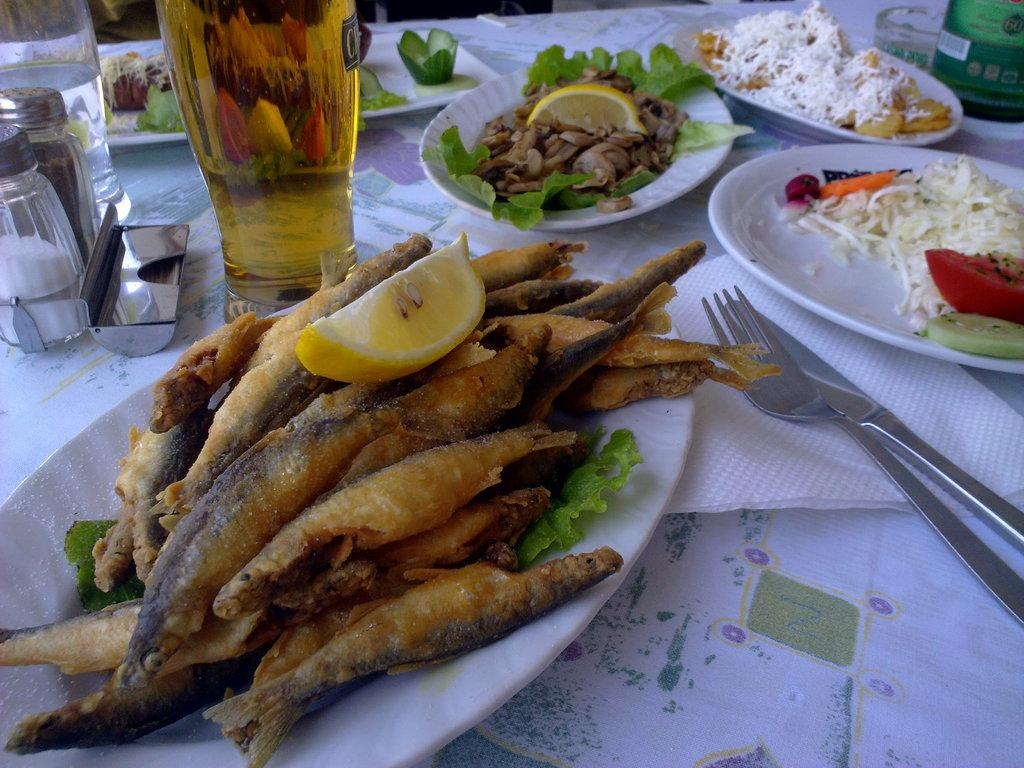What type of items can be seen in the image? There is food in plates, forks, knives, containers, bottles, glass, and a tissue paper in the image. How are these items arranged in the image? All of these items are placed on a table. What might be used for eating the food in the image? Forks and knives can be used for eating the food in the image. What can be used for holding liquids in the image? Bottles and glasses can be used for holding liquids in the image. What type of division is taking place in the image? There is no division taking place in the image; it features various items placed on a table. What role does the secretary play in the image? There is no secretary present in the image; it only contains inanimate objects. 